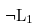Convert formula to latex. <formula><loc_0><loc_0><loc_500><loc_500>\neg L _ { 1 }</formula> 